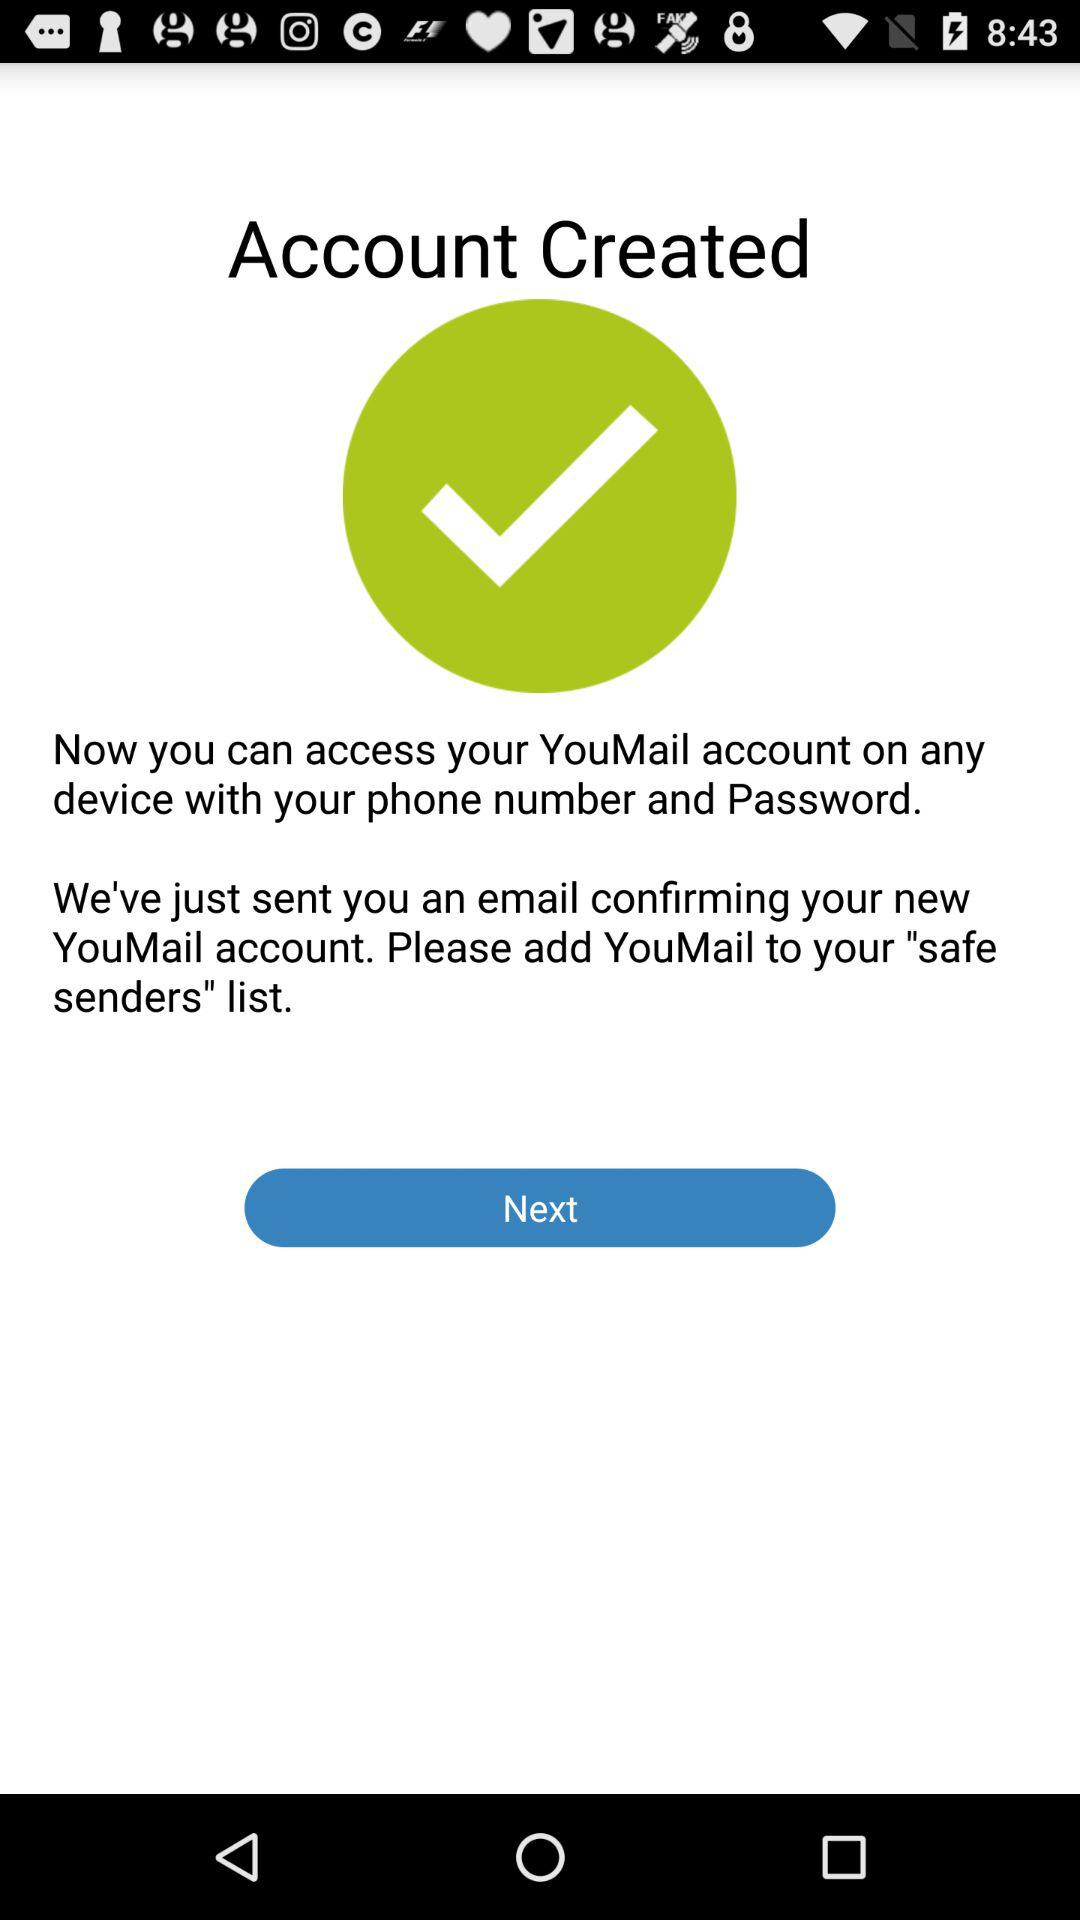What is required to access a YouMail account? You can access your YouMail account with your phone number and password. 